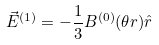Convert formula to latex. <formula><loc_0><loc_0><loc_500><loc_500>\vec { E } ^ { ( 1 ) } = - \frac { 1 } { 3 } B ^ { ( 0 ) } ( \theta r ) \hat { r }</formula> 